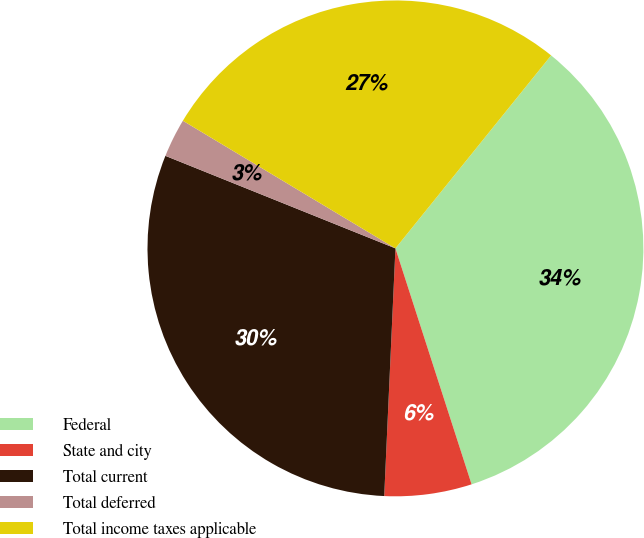<chart> <loc_0><loc_0><loc_500><loc_500><pie_chart><fcel>Federal<fcel>State and city<fcel>Total current<fcel>Total deferred<fcel>Total income taxes applicable<nl><fcel>34.23%<fcel>5.69%<fcel>30.37%<fcel>2.52%<fcel>27.2%<nl></chart> 